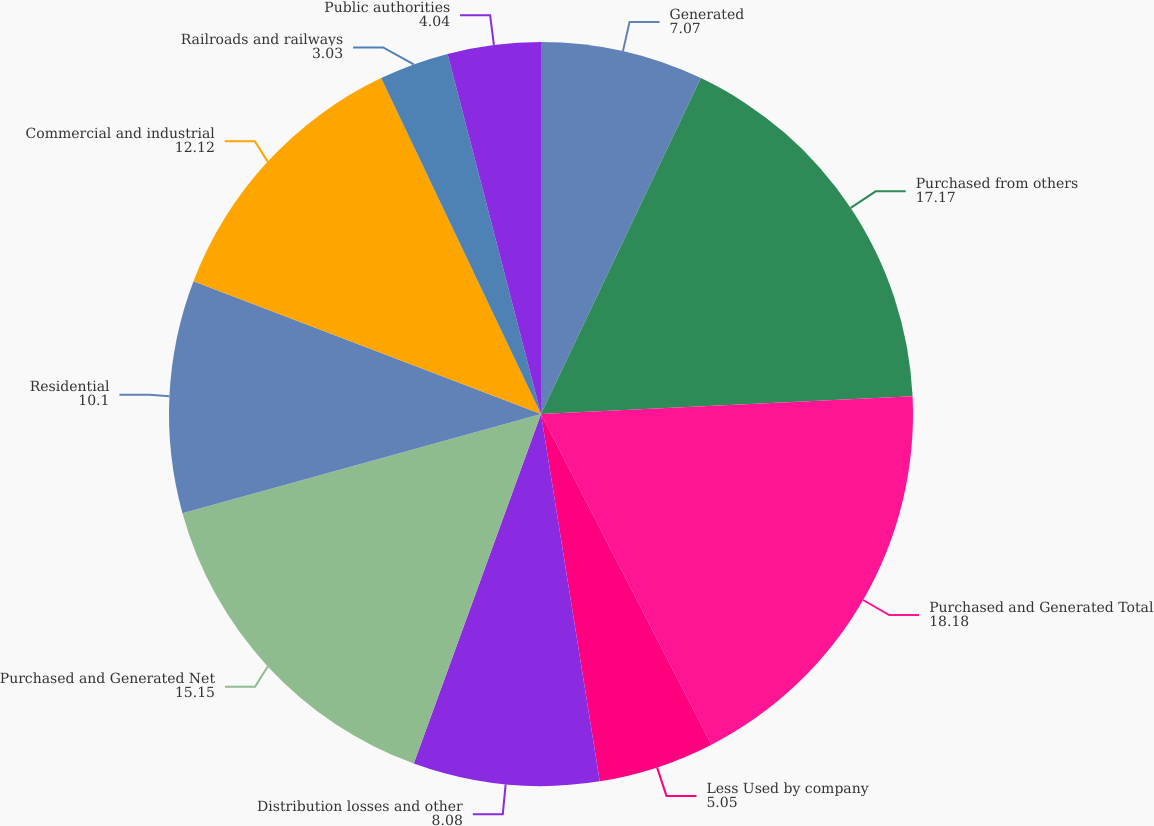Convert chart. <chart><loc_0><loc_0><loc_500><loc_500><pie_chart><fcel>Generated<fcel>Purchased from others<fcel>Purchased and Generated Total<fcel>Less Used by company<fcel>Distribution losses and other<fcel>Purchased and Generated Net<fcel>Residential<fcel>Commercial and industrial<fcel>Railroads and railways<fcel>Public authorities<nl><fcel>7.07%<fcel>17.17%<fcel>18.18%<fcel>5.05%<fcel>8.08%<fcel>15.15%<fcel>10.1%<fcel>12.12%<fcel>3.03%<fcel>4.04%<nl></chart> 